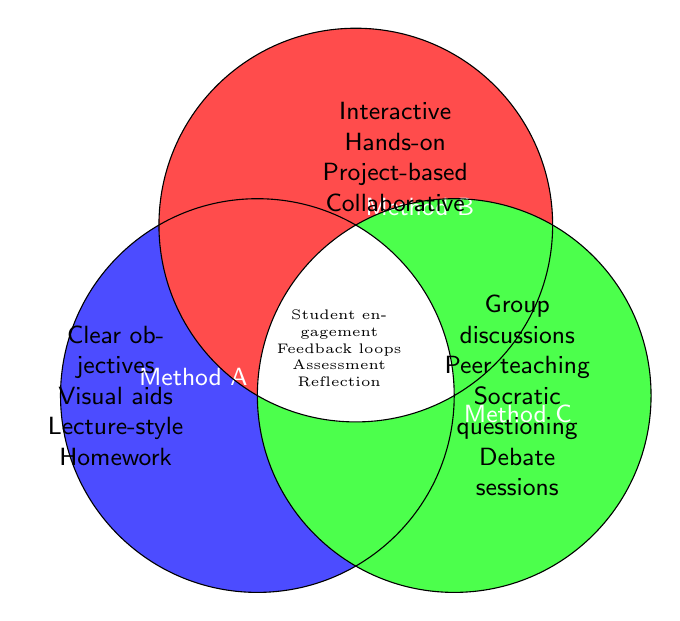What are the common elements found in all methods? The common elements for all methods are listed in the intersection of all three circles in the center of the Venn diagram.
Answer: Student engagement, Feedback loops, Assessment, Reflection Which teaching method includes 'Clear objectives'? Locate the section specific to Method A in the Venn diagram, marked in the circle labeled “Method A”.
Answer: Method A Which methods share 'Group discussions'? Look at the intersection between Method B and Method C in the Venn diagram, excluding the intersection section with Method A.
Answer: Method C What is unique to Method B? Elements unique to Method B appear only in the circle labeled “Method B” without overlapping with other circles.
Answer: Interactive activities, Hands-on learning, Project-based tasks, Collaborative work Which methods include 'Visual aids' and 'Lecture-style teaching'? Determine the method(s) by finding these specific elements in the circle labeled “Method A”, where these elements are listed.
Answer: Method A Are "Homework assignments" and "Debate sessions" shared in any method? Check the circles and their overlapping sections in the Venn diagram where both elements appear. Homework assignments are in Method A, and Debate sessions are in Method C.
Answer: No How many unique elements does Method C have that are not shared with any other method? Identify the elements specific to Method C without any overlap with other methods by looking at the section labeled “Method C” only.
Answer: Four (Group discussions, Peer teaching, Socratic questioning, Debate sessions) Which elements are shared only between Method A and Method B but not Method C? Look at the intersection of Method A and Method B and ensure they don't fall within the intersection with Method C. Since the Venn diagram doesn't show any such shared elements, identify it's empty.
Answer: None What is the relationship between 'Student engagement' and 'Feedback loops'? Both elements are listed in the very center of the Venn diagram where all three circles intersect, meaning they are shared across all methods.
Answer: Shared by all Which methods use 'Assessment strategies'? 'Assessment strategies' are in the center section of all intersections of the Venn diagram, indicating it is common to all methods.
Answer: All methods 